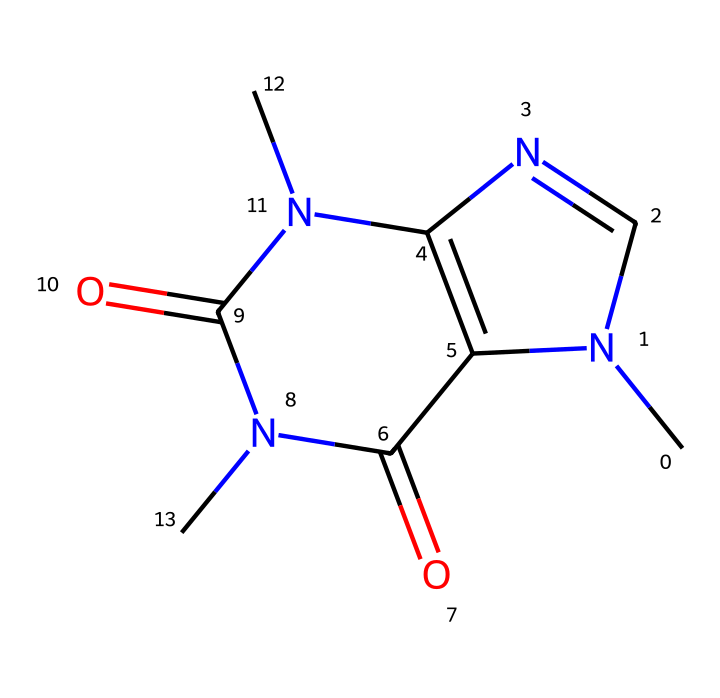What is the molecular formula of this chemical? To determine the molecular formula, we count the number of each type of atom present in the provided SMILES representation: there are 6 Carbon (C), 8 Hydrogen (H), 4 Nitrogen (N), and 2 Oxygen (O) atoms. Therefore, the molecular formula is C6H8N4O2.
Answer: C6H8N4O2 How many nitrogen atoms are in the structure? By analyzing the SMILES structure, we can identify the nitrogen atoms present. There are a total of 4 nitrogen atoms indicated in the chemical structure.
Answer: 4 Is this chemical a primary, secondary, or tertiary amine? A primary amine has one carbon atom attached to the nitrogen, while a secondary amine has two. In this chemical, the nitrogen atoms are bonded to two carbon atoms in some cases, making them secondary amines.
Answer: secondary What is the functional group present in this structure? The SMILES representation reveals that the structure includes imide groups, which are characterized by the presence of nitrogen atoms doubly bonded to carbon atoms.
Answer: imide What type of chemical is caffeine classified as? Caffeine is classified as an alkaloid due to its nitrogen-containing structure and biological effects. The presence of nitrogen and its origin from plant sources supports this classification.
Answer: alkaloid Does this chemical contain any double bonds? Yes, upon examining the structure represented in the SMILES, we can see that there are several double bonds between carbon and nitrogen, indicating the presence of double bonds.
Answer: yes 